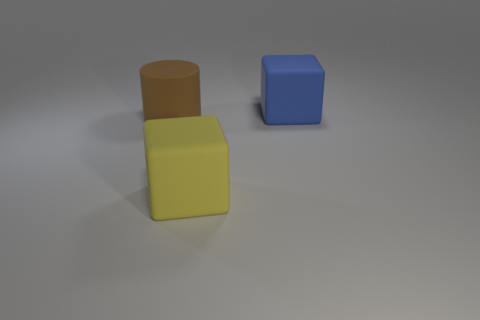Add 3 blue rubber objects. How many objects exist? 6 Subtract all brown blocks. Subtract all blue spheres. How many blocks are left? 2 Subtract all cylinders. How many objects are left? 2 Add 1 small blue matte spheres. How many small blue matte spheres exist? 1 Subtract 0 cyan cylinders. How many objects are left? 3 Subtract all large yellow matte cubes. Subtract all brown cylinders. How many objects are left? 1 Add 2 brown matte cylinders. How many brown matte cylinders are left? 3 